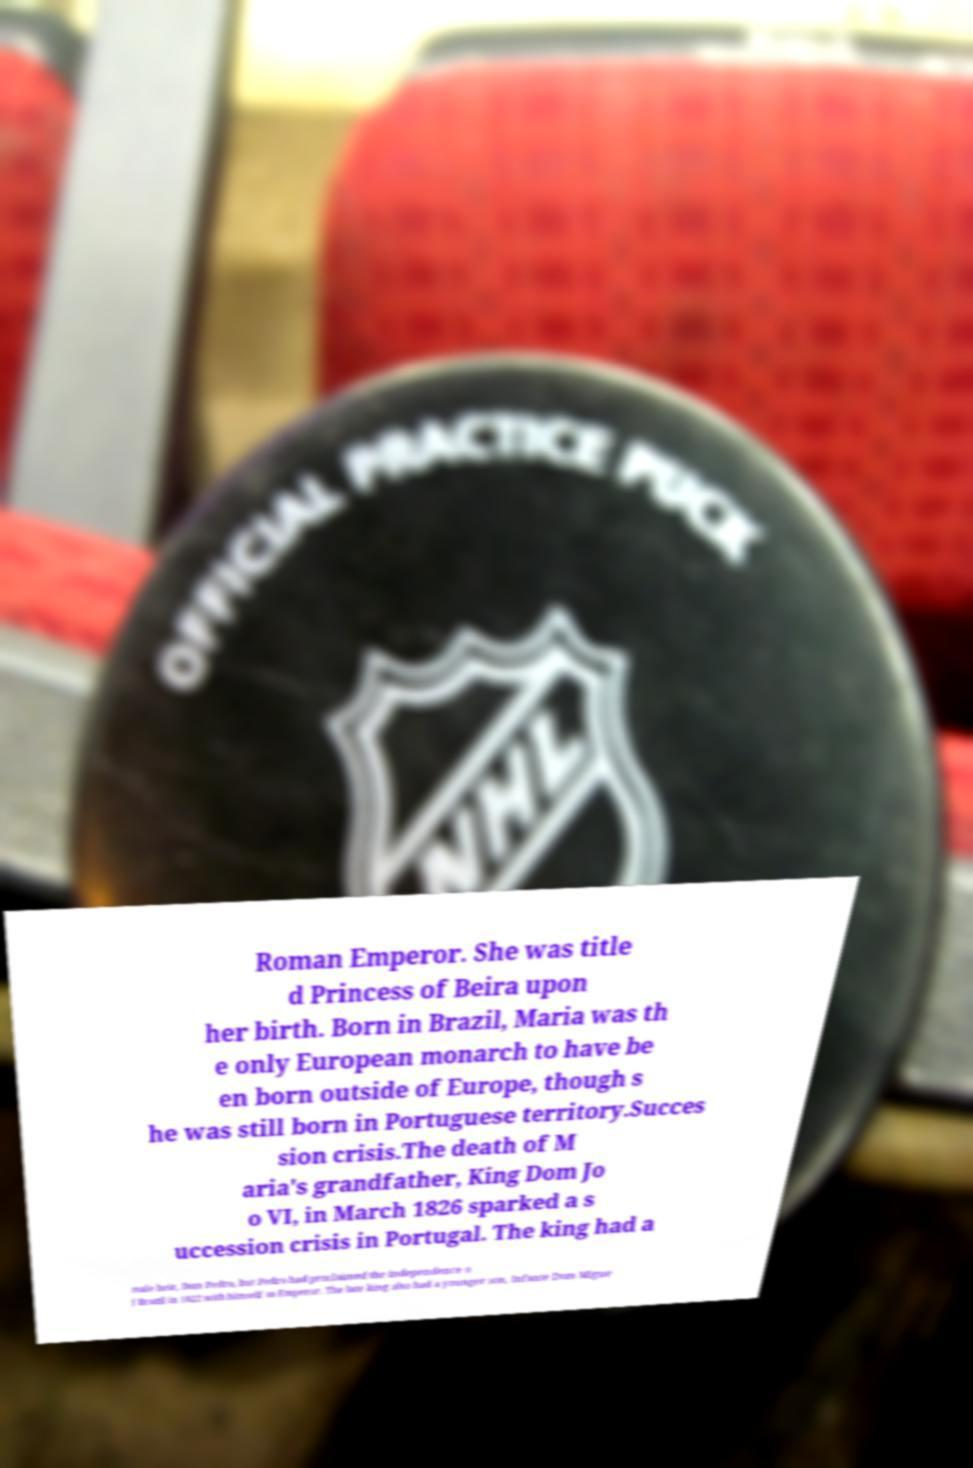Please read and relay the text visible in this image. What does it say? Roman Emperor. She was title d Princess of Beira upon her birth. Born in Brazil, Maria was th e only European monarch to have be en born outside of Europe, though s he was still born in Portuguese territory.Succes sion crisis.The death of M aria's grandfather, King Dom Jo o VI, in March 1826 sparked a s uccession crisis in Portugal. The king had a male heir, Dom Pedro, but Pedro had proclaimed the independence o f Brazil in 1822 with himself as Emperor. The late king also had a younger son, Infante Dom Migue 